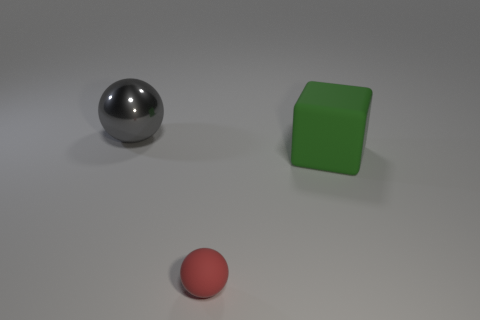Add 3 big purple cylinders. How many objects exist? 6 Subtract all cubes. How many objects are left? 2 Subtract all big green matte objects. Subtract all tiny rubber things. How many objects are left? 1 Add 2 red matte things. How many red matte things are left? 3 Add 2 balls. How many balls exist? 4 Subtract 0 purple cubes. How many objects are left? 3 